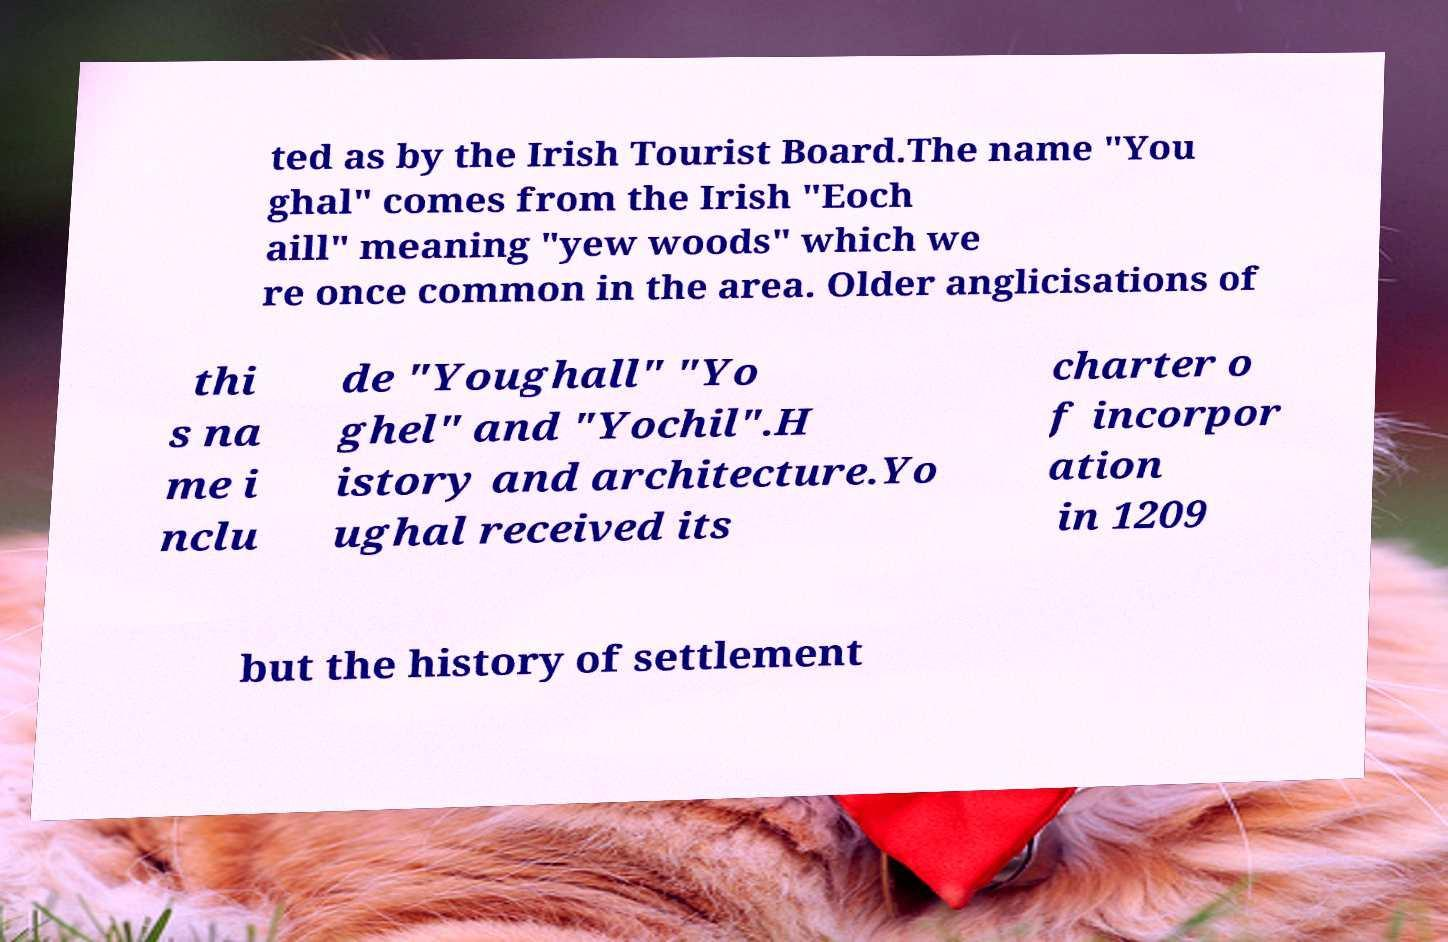Please read and relay the text visible in this image. What does it say? ted as by the Irish Tourist Board.The name "You ghal" comes from the Irish "Eoch aill" meaning "yew woods" which we re once common in the area. Older anglicisations of thi s na me i nclu de "Youghall" "Yo ghel" and "Yochil".H istory and architecture.Yo ughal received its charter o f incorpor ation in 1209 but the history of settlement 